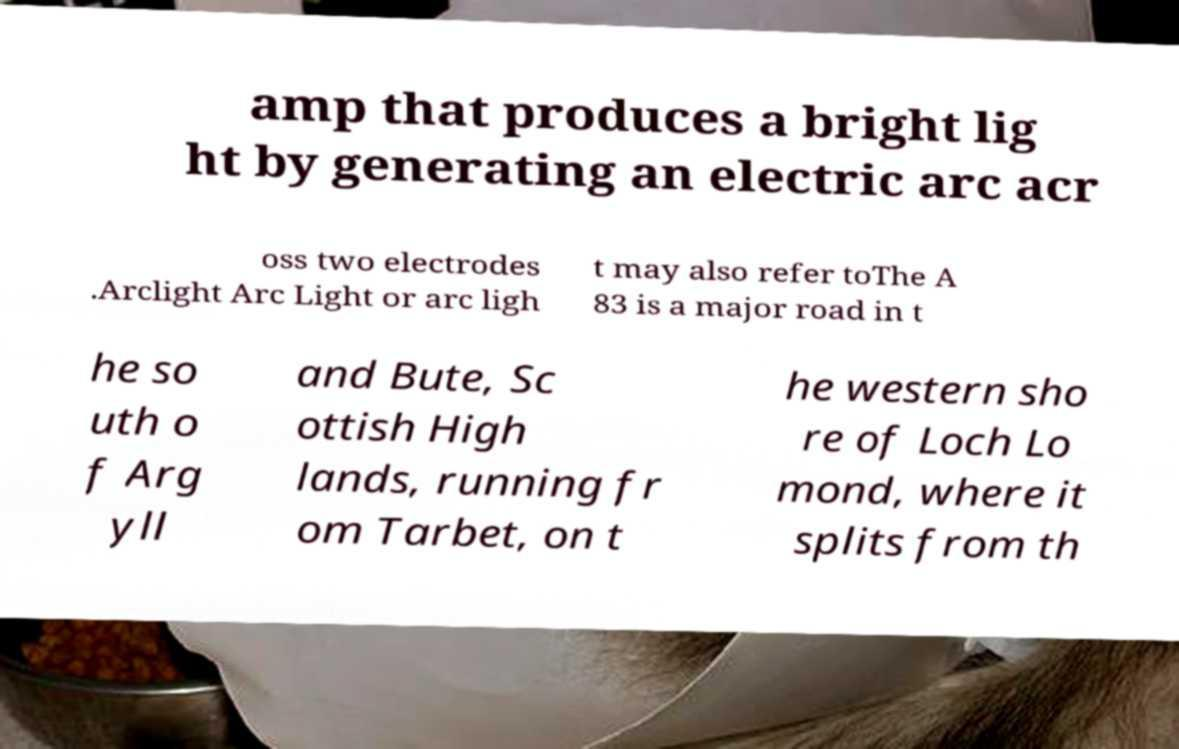Could you extract and type out the text from this image? amp that produces a bright lig ht by generating an electric arc acr oss two electrodes .Arclight Arc Light or arc ligh t may also refer toThe A 83 is a major road in t he so uth o f Arg yll and Bute, Sc ottish High lands, running fr om Tarbet, on t he western sho re of Loch Lo mond, where it splits from th 